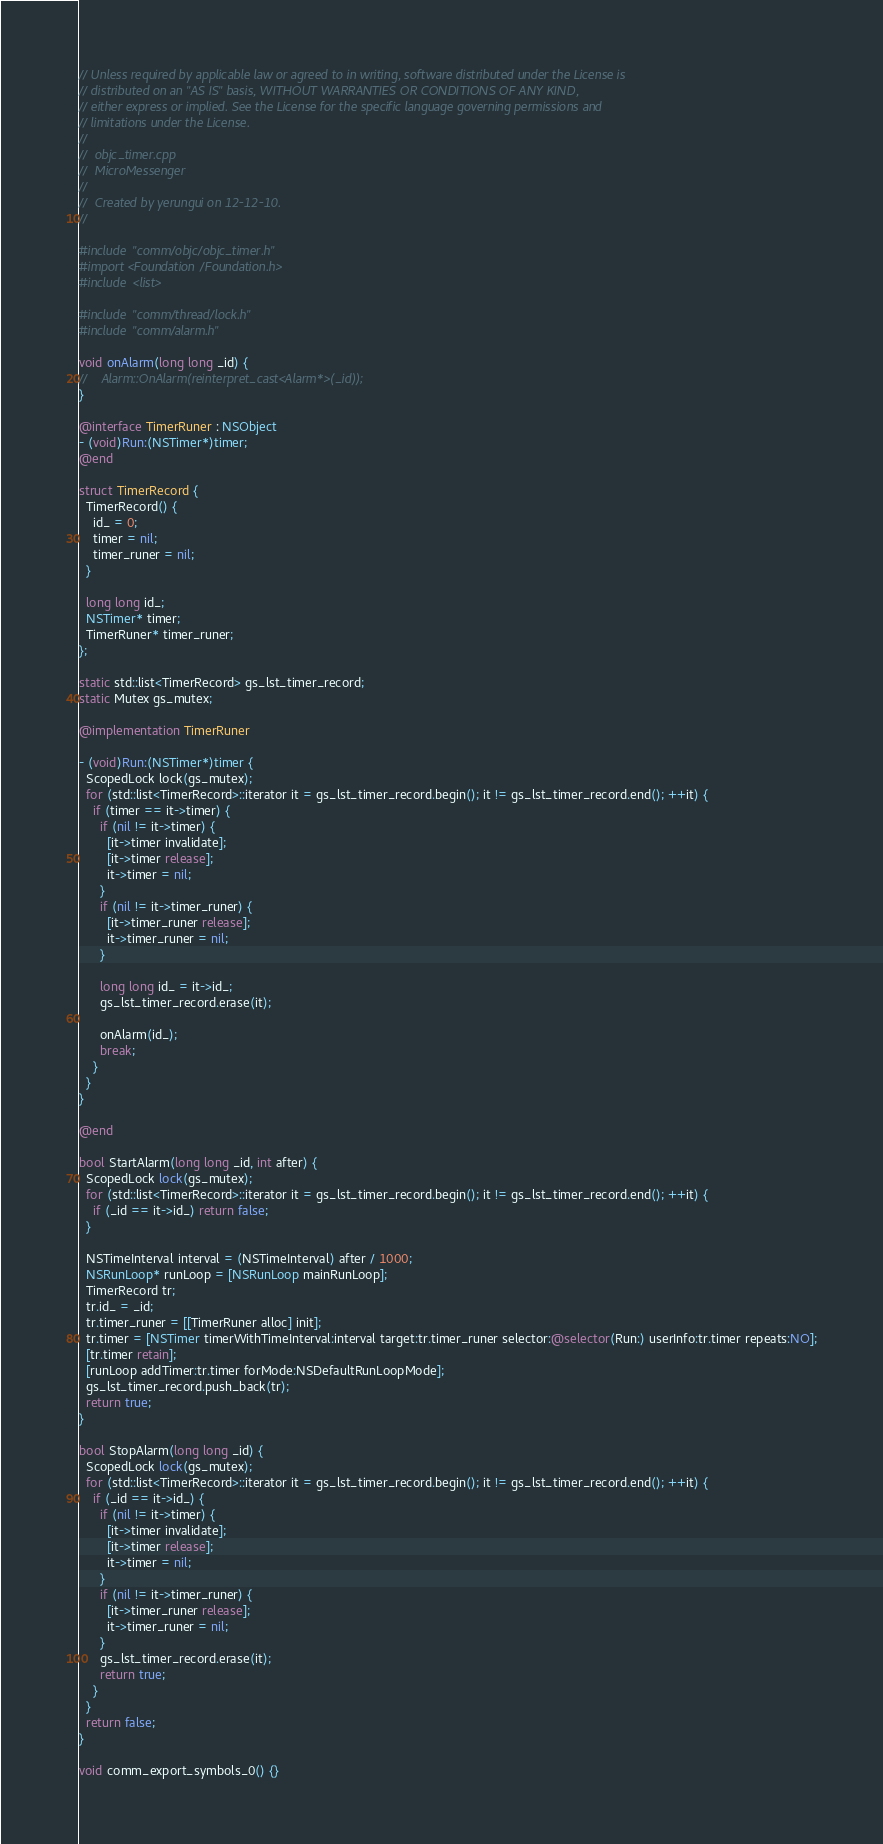Convert code to text. <code><loc_0><loc_0><loc_500><loc_500><_ObjectiveC_>// Unless required by applicable law or agreed to in writing, software distributed under the License is
// distributed on an "AS IS" basis, WITHOUT WARRANTIES OR CONDITIONS OF ANY KIND,
// either express or implied. See the License for the specific language governing permissions and
// limitations under the License.
//
//  objc_timer.cpp
//  MicroMessenger
//
//  Created by yerungui on 12-12-10.
//

#include "comm/objc/objc_timer.h"
#import <Foundation/Foundation.h>
#include <list>

#include "comm/thread/lock.h"
#include "comm/alarm.h"

void onAlarm(long long _id) {
//    Alarm::OnAlarm(reinterpret_cast<Alarm*>(_id));
}

@interface TimerRuner : NSObject
- (void)Run:(NSTimer*)timer;
@end

struct TimerRecord {
  TimerRecord() {
    id_ = 0;
    timer = nil;
    timer_runer = nil;
  }

  long long id_;
  NSTimer* timer;
  TimerRuner* timer_runer;
};

static std::list<TimerRecord> gs_lst_timer_record;
static Mutex gs_mutex;

@implementation TimerRuner

- (void)Run:(NSTimer*)timer {
  ScopedLock lock(gs_mutex);
  for (std::list<TimerRecord>::iterator it = gs_lst_timer_record.begin(); it != gs_lst_timer_record.end(); ++it) {
    if (timer == it->timer) {
      if (nil != it->timer) {
        [it->timer invalidate];
        [it->timer release];
        it->timer = nil;
      }
      if (nil != it->timer_runer) {
        [it->timer_runer release];
        it->timer_runer = nil;
      }

      long long id_ = it->id_;
      gs_lst_timer_record.erase(it);

      onAlarm(id_);
      break;
    }
  }
}

@end

bool StartAlarm(long long _id, int after) {
  ScopedLock lock(gs_mutex);
  for (std::list<TimerRecord>::iterator it = gs_lst_timer_record.begin(); it != gs_lst_timer_record.end(); ++it) {
    if (_id == it->id_) return false;
  }

  NSTimeInterval interval = (NSTimeInterval) after / 1000;
  NSRunLoop* runLoop = [NSRunLoop mainRunLoop];
  TimerRecord tr;
  tr.id_ = _id;
  tr.timer_runer = [[TimerRuner alloc] init];
  tr.timer = [NSTimer timerWithTimeInterval:interval target:tr.timer_runer selector:@selector(Run:) userInfo:tr.timer repeats:NO];
  [tr.timer retain];
  [runLoop addTimer:tr.timer forMode:NSDefaultRunLoopMode];
  gs_lst_timer_record.push_back(tr);
  return true;
}

bool StopAlarm(long long _id) {
  ScopedLock lock(gs_mutex);
  for (std::list<TimerRecord>::iterator it = gs_lst_timer_record.begin(); it != gs_lst_timer_record.end(); ++it) {
    if (_id == it->id_) {
      if (nil != it->timer) {
        [it->timer invalidate];
        [it->timer release];
        it->timer = nil;
      }
      if (nil != it->timer_runer) {
        [it->timer_runer release];
        it->timer_runer = nil;
      }
      gs_lst_timer_record.erase(it);
      return true;
    }
  }
  return false;
}

void comm_export_symbols_0() {}
</code> 